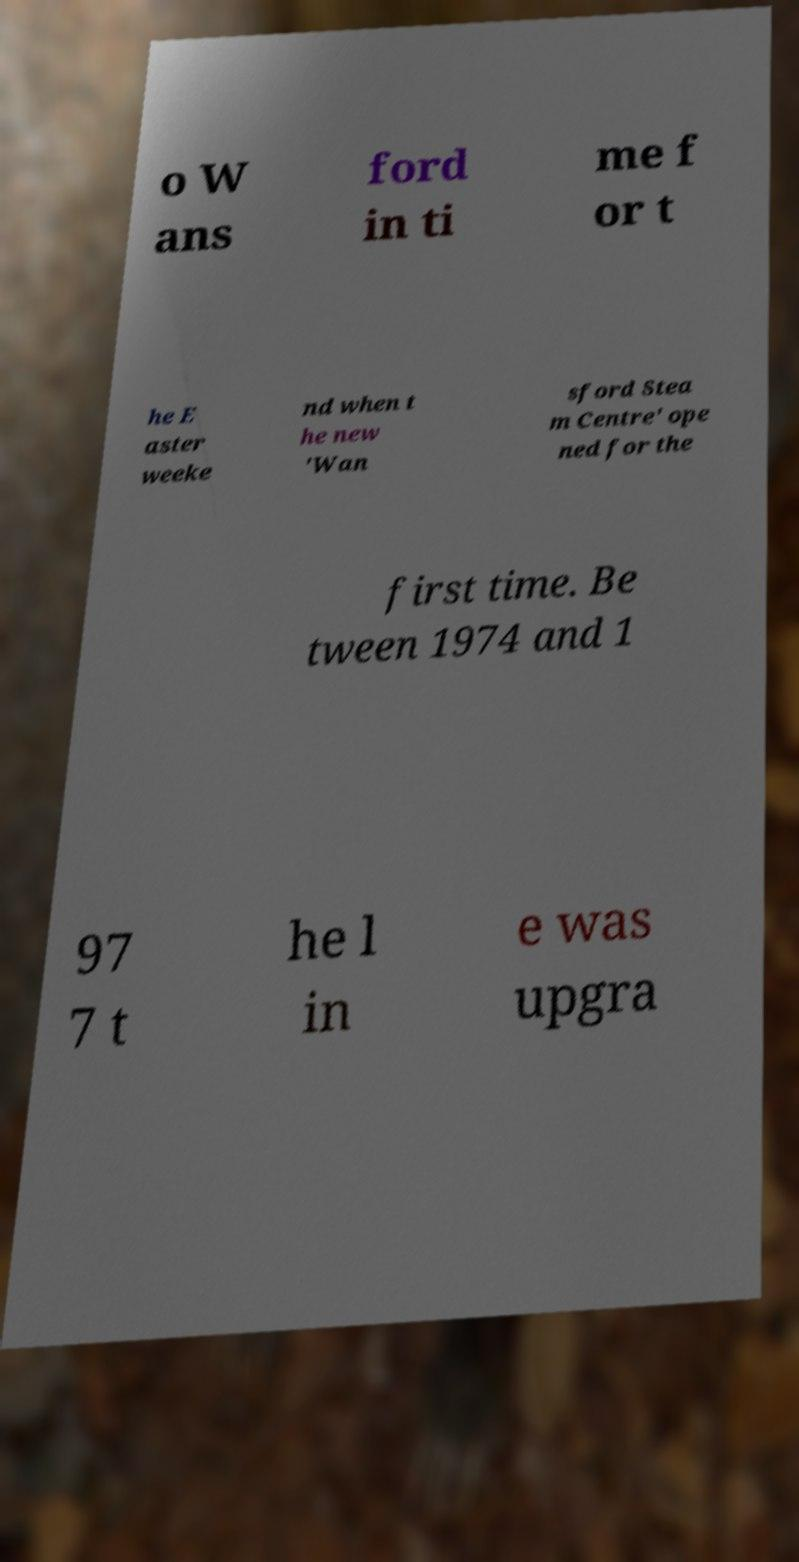Please identify and transcribe the text found in this image. o W ans ford in ti me f or t he E aster weeke nd when t he new 'Wan sford Stea m Centre' ope ned for the first time. Be tween 1974 and 1 97 7 t he l in e was upgra 